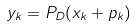Convert formula to latex. <formula><loc_0><loc_0><loc_500><loc_500>y _ { k } = P _ { D } ( x _ { k } + p _ { k } )</formula> 